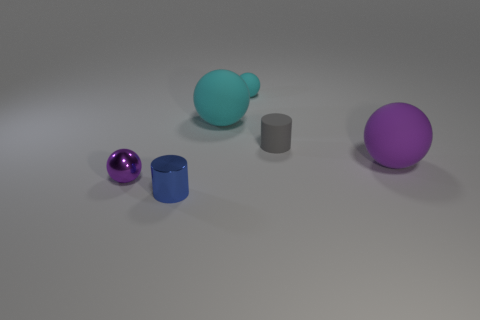How many small objects are either cyan metal cubes or cyan matte objects?
Provide a short and direct response. 1. Are there more small blue things than purple balls?
Ensure brevity in your answer.  No. What size is the purple sphere that is made of the same material as the small cyan thing?
Ensure brevity in your answer.  Large. There is a purple ball that is on the right side of the small purple sphere; does it have the same size as the cyan rubber thing in front of the small cyan rubber thing?
Keep it short and to the point. Yes. What number of objects are big matte things that are to the right of the small cyan thing or gray shiny spheres?
Your response must be concise. 1. Are there fewer tiny blue objects than things?
Keep it short and to the point. Yes. What shape is the small shiny object that is to the left of the small metal object that is in front of the purple ball left of the tiny metallic cylinder?
Your response must be concise. Sphere. What is the shape of the matte object that is the same color as the small metallic sphere?
Offer a very short reply. Sphere. Are any metallic balls visible?
Offer a very short reply. Yes. There is a shiny cylinder; does it have the same size as the cylinder that is behind the tiny purple metal sphere?
Your answer should be very brief. Yes. 